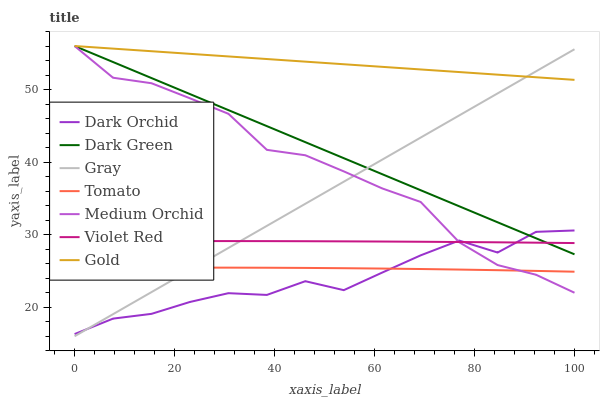Does Dark Orchid have the minimum area under the curve?
Answer yes or no. Yes. Does Gold have the maximum area under the curve?
Answer yes or no. Yes. Does Gray have the minimum area under the curve?
Answer yes or no. No. Does Gray have the maximum area under the curve?
Answer yes or no. No. Is Dark Green the smoothest?
Answer yes or no. Yes. Is Dark Orchid the roughest?
Answer yes or no. Yes. Is Gray the smoothest?
Answer yes or no. No. Is Gray the roughest?
Answer yes or no. No. Does Gray have the lowest value?
Answer yes or no. Yes. Does Violet Red have the lowest value?
Answer yes or no. No. Does Dark Green have the highest value?
Answer yes or no. Yes. Does Gray have the highest value?
Answer yes or no. No. Is Tomato less than Dark Green?
Answer yes or no. Yes. Is Gold greater than Tomato?
Answer yes or no. Yes. Does Gray intersect Dark Green?
Answer yes or no. Yes. Is Gray less than Dark Green?
Answer yes or no. No. Is Gray greater than Dark Green?
Answer yes or no. No. Does Tomato intersect Dark Green?
Answer yes or no. No. 